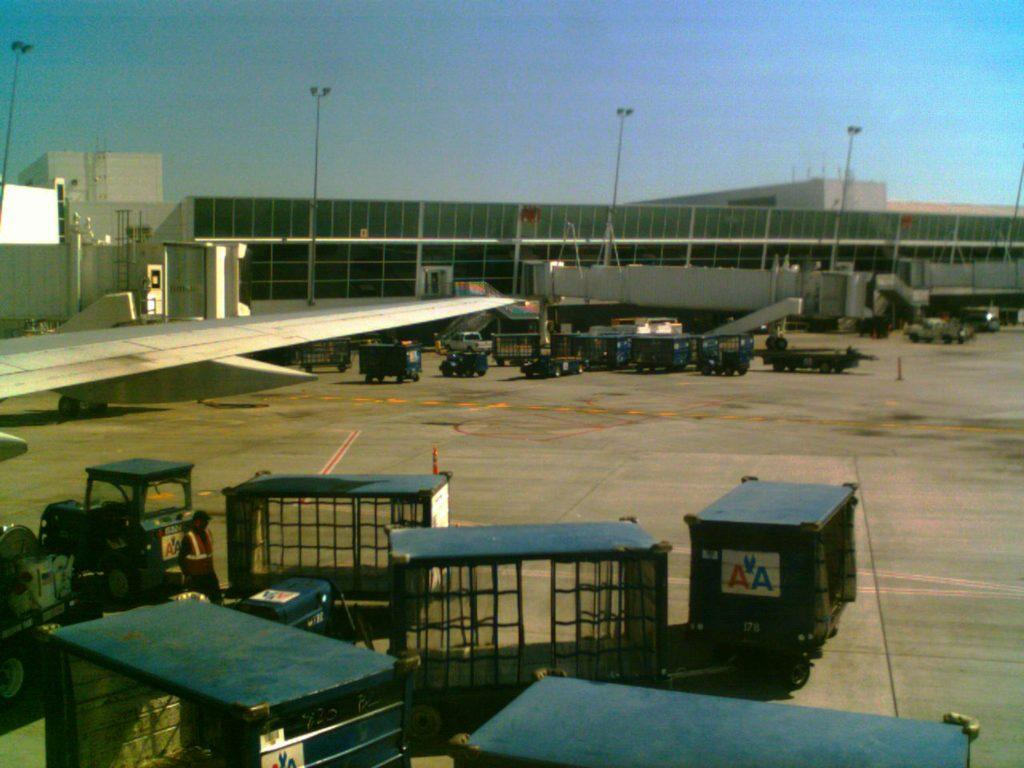<image>
Write a terse but informative summary of the picture. the letters AA that are on a trash can 